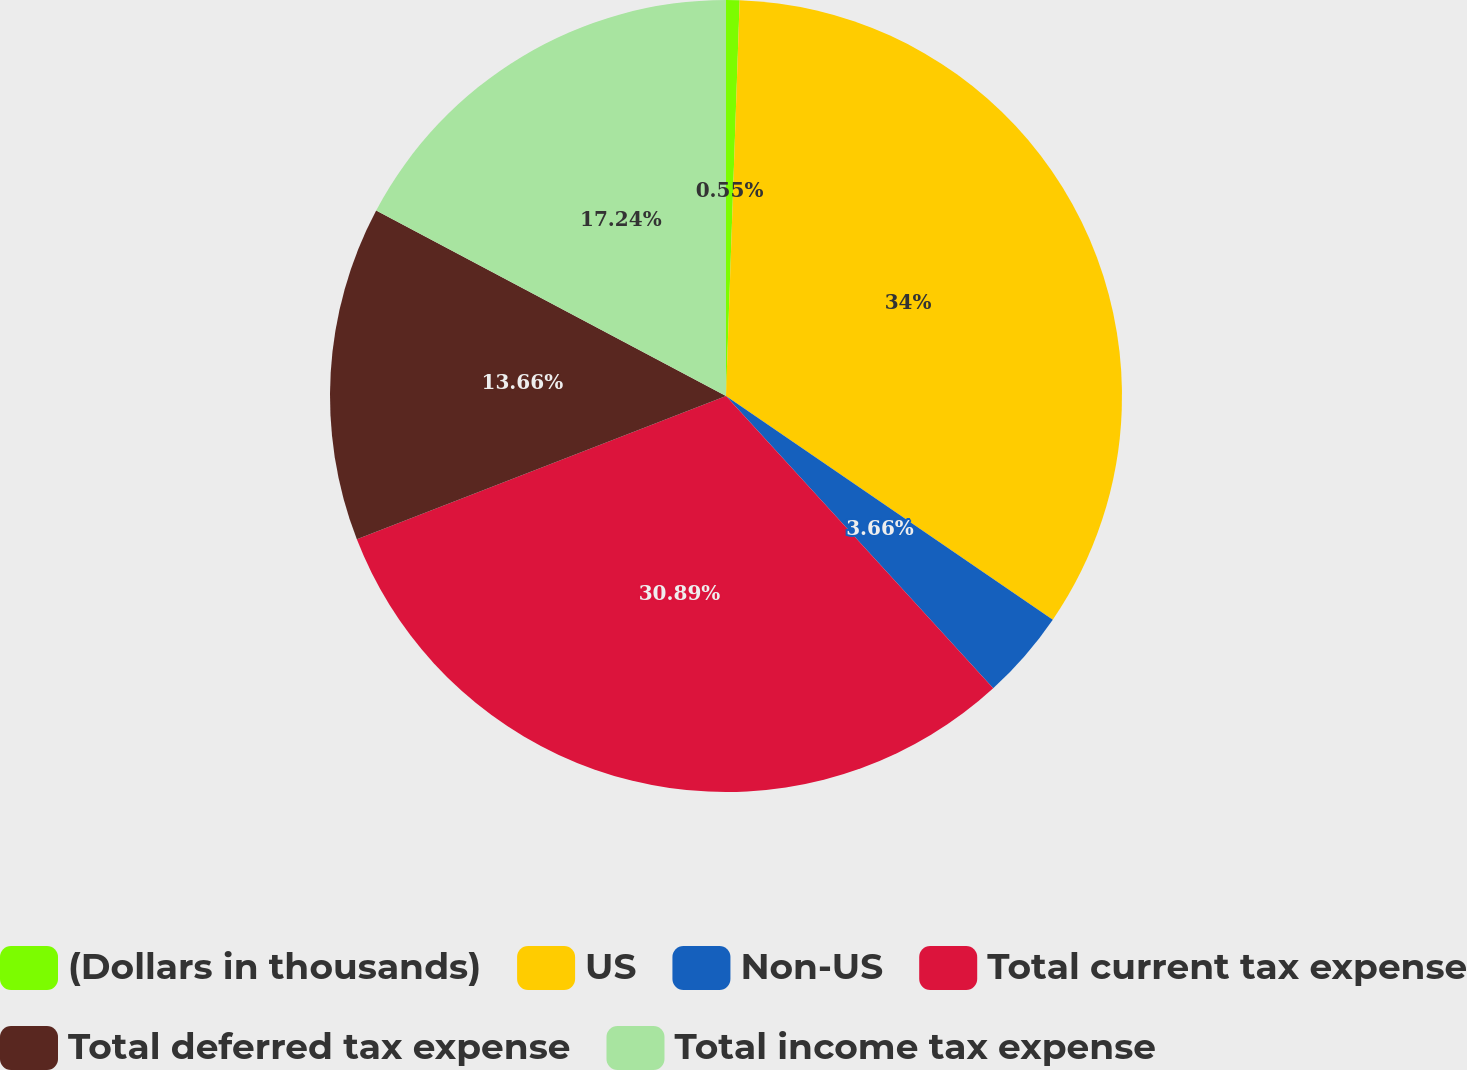Convert chart. <chart><loc_0><loc_0><loc_500><loc_500><pie_chart><fcel>(Dollars in thousands)<fcel>US<fcel>Non-US<fcel>Total current tax expense<fcel>Total deferred tax expense<fcel>Total income tax expense<nl><fcel>0.55%<fcel>34.01%<fcel>3.66%<fcel>30.9%<fcel>13.66%<fcel>17.24%<nl></chart> 